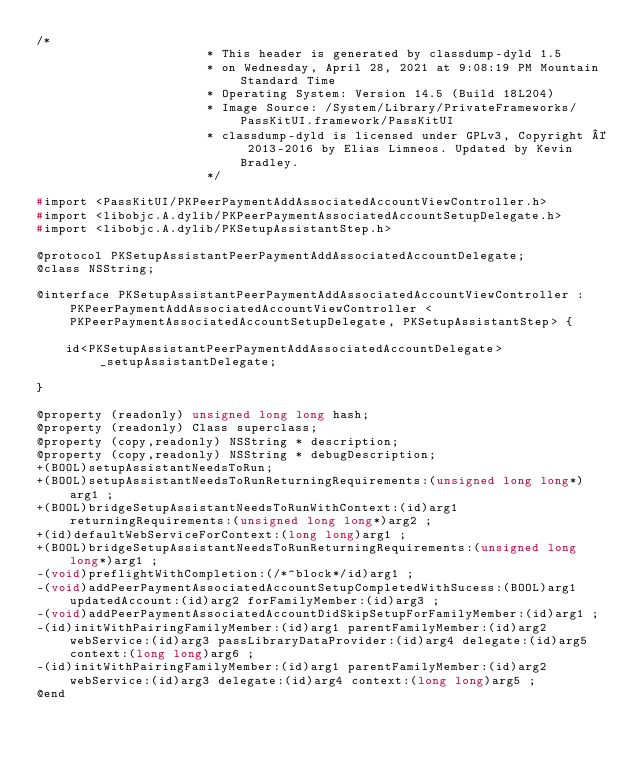<code> <loc_0><loc_0><loc_500><loc_500><_C_>/*
                       * This header is generated by classdump-dyld 1.5
                       * on Wednesday, April 28, 2021 at 9:08:19 PM Mountain Standard Time
                       * Operating System: Version 14.5 (Build 18L204)
                       * Image Source: /System/Library/PrivateFrameworks/PassKitUI.framework/PassKitUI
                       * classdump-dyld is licensed under GPLv3, Copyright © 2013-2016 by Elias Limneos. Updated by Kevin Bradley.
                       */

#import <PassKitUI/PKPeerPaymentAddAssociatedAccountViewController.h>
#import <libobjc.A.dylib/PKPeerPaymentAssociatedAccountSetupDelegate.h>
#import <libobjc.A.dylib/PKSetupAssistantStep.h>

@protocol PKSetupAssistantPeerPaymentAddAssociatedAccountDelegate;
@class NSString;

@interface PKSetupAssistantPeerPaymentAddAssociatedAccountViewController : PKPeerPaymentAddAssociatedAccountViewController <PKPeerPaymentAssociatedAccountSetupDelegate, PKSetupAssistantStep> {

	id<PKSetupAssistantPeerPaymentAddAssociatedAccountDelegate> _setupAssistantDelegate;

}

@property (readonly) unsigned long long hash; 
@property (readonly) Class superclass; 
@property (copy,readonly) NSString * description; 
@property (copy,readonly) NSString * debugDescription; 
+(BOOL)setupAssistantNeedsToRun;
+(BOOL)setupAssistantNeedsToRunReturningRequirements:(unsigned long long*)arg1 ;
+(BOOL)bridgeSetupAssistantNeedsToRunWithContext:(id)arg1 returningRequirements:(unsigned long long*)arg2 ;
+(id)defaultWebServiceForContext:(long long)arg1 ;
+(BOOL)bridgeSetupAssistantNeedsToRunReturningRequirements:(unsigned long long*)arg1 ;
-(void)preflightWithCompletion:(/*^block*/id)arg1 ;
-(void)addPeerPaymentAssociatedAccountSetupCompletedWithSucess:(BOOL)arg1 updatedAccount:(id)arg2 forFamilyMember:(id)arg3 ;
-(void)addPeerPaymentAssociatedAccountDidSkipSetupForFamilyMember:(id)arg1 ;
-(id)initWithPairingFamilyMember:(id)arg1 parentFamilyMember:(id)arg2 webService:(id)arg3 passLibraryDataProvider:(id)arg4 delegate:(id)arg5 context:(long long)arg6 ;
-(id)initWithPairingFamilyMember:(id)arg1 parentFamilyMember:(id)arg2 webService:(id)arg3 delegate:(id)arg4 context:(long long)arg5 ;
@end

</code> 